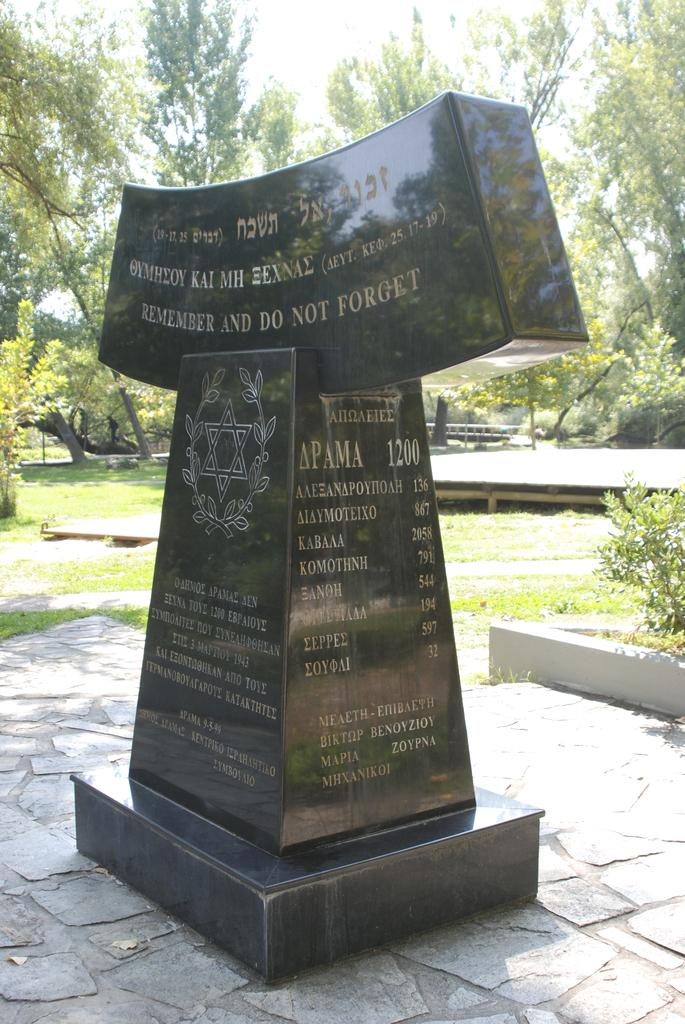What is the main subject in the foreground of the image? There is a memorial in the foreground of the image. What can be read on the memorial? There is text on the memorial. What type of vegetation is visible in the background of the image? There are trees visible in the background of the image. What is visible at the top of the image? The sky is visible at the top of the image. What type of ground is present at the bottom of the image? Grass is present at the bottom of the image. Can you see any branches on the yak in the image? There is no yak present in the image, so it is not possible to see any branches on it. 